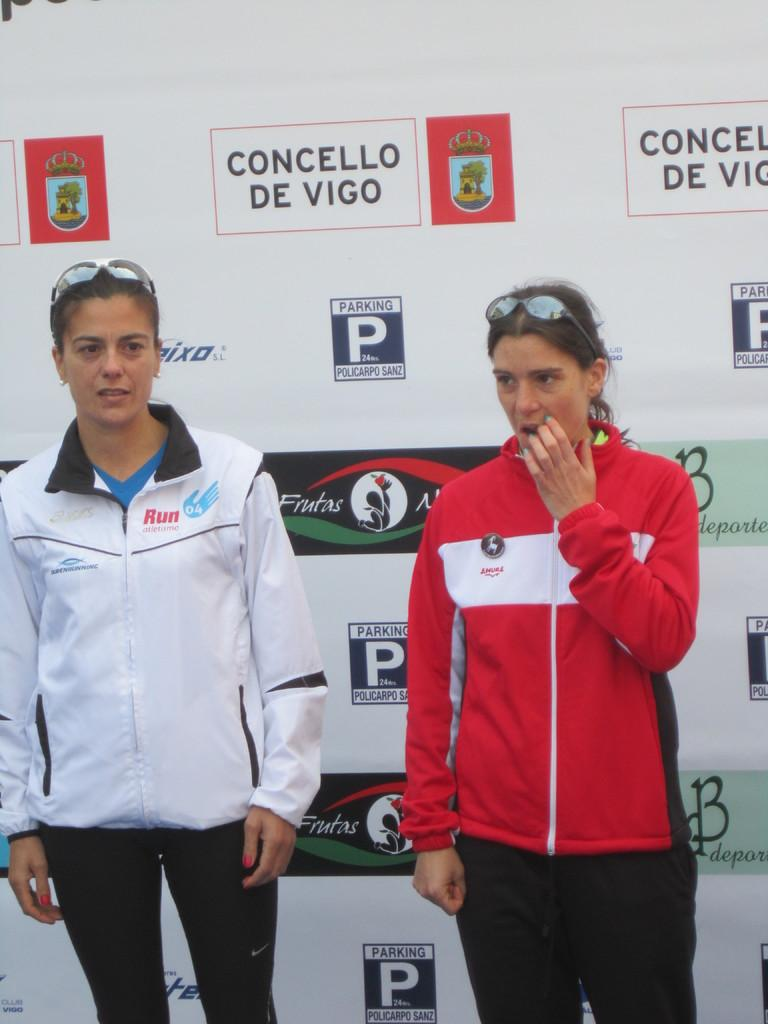<image>
Summarize the visual content of the image. two women in from of a banner wall sponsored by Concello De Vigo 